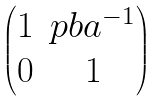Convert formula to latex. <formula><loc_0><loc_0><loc_500><loc_500>\begin{pmatrix} 1 & p b a ^ { - 1 } \\ 0 & 1 \end{pmatrix}</formula> 